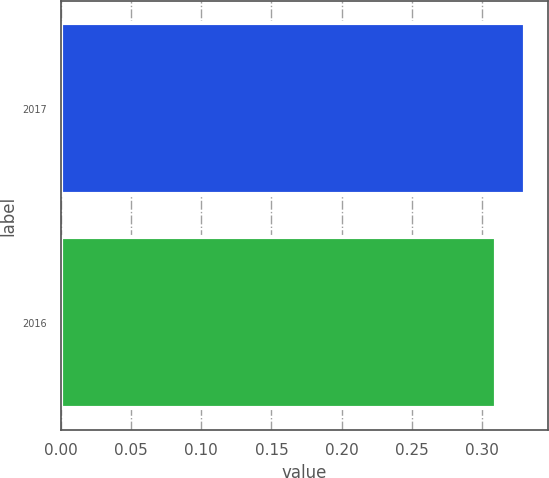Convert chart to OTSL. <chart><loc_0><loc_0><loc_500><loc_500><bar_chart><fcel>2017<fcel>2016<nl><fcel>0.33<fcel>0.31<nl></chart> 